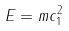<formula> <loc_0><loc_0><loc_500><loc_500>E = m c _ { 1 } ^ { 2 }</formula> 